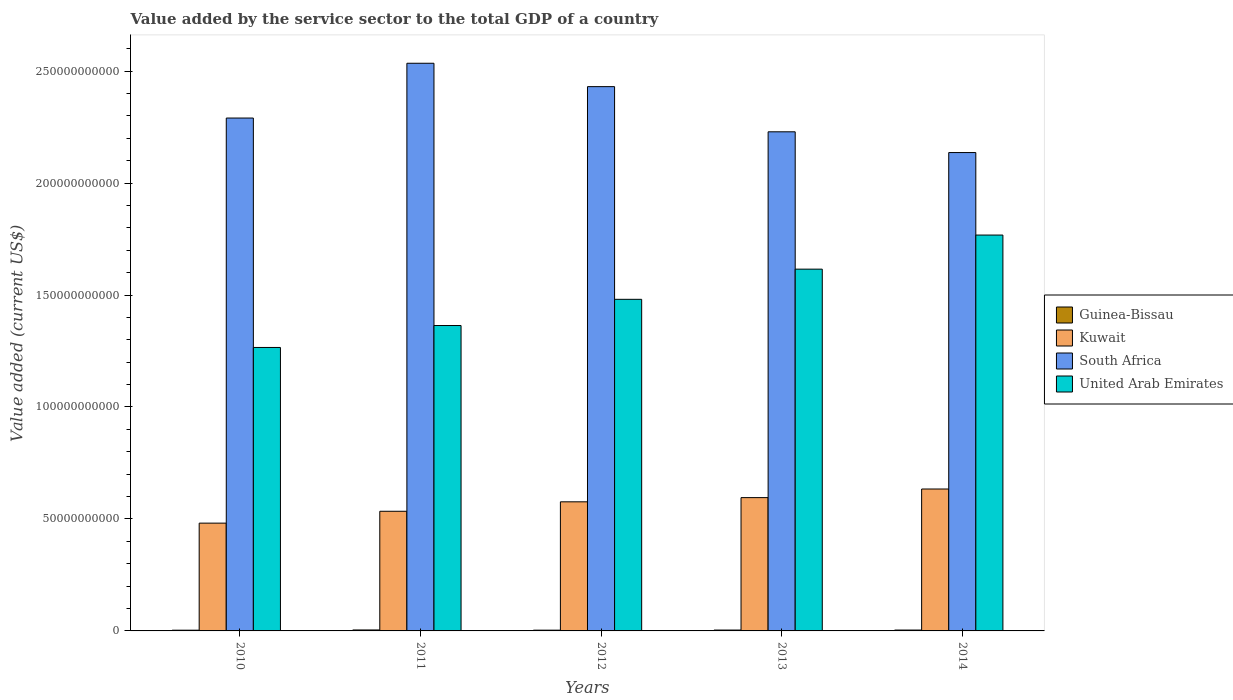Are the number of bars on each tick of the X-axis equal?
Provide a short and direct response. Yes. How many bars are there on the 2nd tick from the left?
Keep it short and to the point. 4. How many bars are there on the 2nd tick from the right?
Ensure brevity in your answer.  4. In how many cases, is the number of bars for a given year not equal to the number of legend labels?
Your answer should be very brief. 0. What is the value added by the service sector to the total GDP in Kuwait in 2013?
Ensure brevity in your answer.  5.95e+1. Across all years, what is the maximum value added by the service sector to the total GDP in Kuwait?
Your response must be concise. 6.34e+1. Across all years, what is the minimum value added by the service sector to the total GDP in Guinea-Bissau?
Your response must be concise. 3.25e+08. In which year was the value added by the service sector to the total GDP in South Africa minimum?
Make the answer very short. 2014. What is the total value added by the service sector to the total GDP in South Africa in the graph?
Give a very brief answer. 1.16e+12. What is the difference between the value added by the service sector to the total GDP in South Africa in 2012 and that in 2013?
Ensure brevity in your answer.  2.02e+1. What is the difference between the value added by the service sector to the total GDP in South Africa in 2012 and the value added by the service sector to the total GDP in Kuwait in 2013?
Your answer should be very brief. 1.84e+11. What is the average value added by the service sector to the total GDP in Kuwait per year?
Make the answer very short. 5.64e+1. In the year 2013, what is the difference between the value added by the service sector to the total GDP in Kuwait and value added by the service sector to the total GDP in Guinea-Bissau?
Offer a terse response. 5.91e+1. In how many years, is the value added by the service sector to the total GDP in Guinea-Bissau greater than 230000000000 US$?
Ensure brevity in your answer.  0. What is the ratio of the value added by the service sector to the total GDP in Guinea-Bissau in 2012 to that in 2013?
Your response must be concise. 0.88. Is the difference between the value added by the service sector to the total GDP in Kuwait in 2013 and 2014 greater than the difference between the value added by the service sector to the total GDP in Guinea-Bissau in 2013 and 2014?
Your answer should be very brief. No. What is the difference between the highest and the second highest value added by the service sector to the total GDP in Kuwait?
Offer a very short reply. 3.85e+09. What is the difference between the highest and the lowest value added by the service sector to the total GDP in United Arab Emirates?
Offer a terse response. 5.02e+1. Is it the case that in every year, the sum of the value added by the service sector to the total GDP in United Arab Emirates and value added by the service sector to the total GDP in Guinea-Bissau is greater than the sum of value added by the service sector to the total GDP in South Africa and value added by the service sector to the total GDP in Kuwait?
Make the answer very short. Yes. What does the 4th bar from the left in 2013 represents?
Keep it short and to the point. United Arab Emirates. What does the 2nd bar from the right in 2013 represents?
Your answer should be compact. South Africa. Are all the bars in the graph horizontal?
Give a very brief answer. No. How many years are there in the graph?
Provide a succinct answer. 5. Where does the legend appear in the graph?
Give a very brief answer. Center right. What is the title of the graph?
Keep it short and to the point. Value added by the service sector to the total GDP of a country. What is the label or title of the X-axis?
Provide a short and direct response. Years. What is the label or title of the Y-axis?
Offer a terse response. Value added (current US$). What is the Value added (current US$) in Guinea-Bissau in 2010?
Provide a succinct answer. 3.25e+08. What is the Value added (current US$) in Kuwait in 2010?
Provide a short and direct response. 4.81e+1. What is the Value added (current US$) in South Africa in 2010?
Offer a terse response. 2.29e+11. What is the Value added (current US$) in United Arab Emirates in 2010?
Give a very brief answer. 1.27e+11. What is the Value added (current US$) of Guinea-Bissau in 2011?
Your answer should be compact. 4.27e+08. What is the Value added (current US$) of Kuwait in 2011?
Keep it short and to the point. 5.34e+1. What is the Value added (current US$) in South Africa in 2011?
Keep it short and to the point. 2.53e+11. What is the Value added (current US$) in United Arab Emirates in 2011?
Provide a succinct answer. 1.36e+11. What is the Value added (current US$) in Guinea-Bissau in 2012?
Give a very brief answer. 3.38e+08. What is the Value added (current US$) in Kuwait in 2012?
Provide a succinct answer. 5.77e+1. What is the Value added (current US$) of South Africa in 2012?
Your answer should be compact. 2.43e+11. What is the Value added (current US$) of United Arab Emirates in 2012?
Keep it short and to the point. 1.48e+11. What is the Value added (current US$) in Guinea-Bissau in 2013?
Your answer should be compact. 3.86e+08. What is the Value added (current US$) of Kuwait in 2013?
Your response must be concise. 5.95e+1. What is the Value added (current US$) of South Africa in 2013?
Your response must be concise. 2.23e+11. What is the Value added (current US$) in United Arab Emirates in 2013?
Offer a very short reply. 1.62e+11. What is the Value added (current US$) in Guinea-Bissau in 2014?
Give a very brief answer. 3.89e+08. What is the Value added (current US$) in Kuwait in 2014?
Give a very brief answer. 6.34e+1. What is the Value added (current US$) of South Africa in 2014?
Keep it short and to the point. 2.14e+11. What is the Value added (current US$) of United Arab Emirates in 2014?
Ensure brevity in your answer.  1.77e+11. Across all years, what is the maximum Value added (current US$) in Guinea-Bissau?
Ensure brevity in your answer.  4.27e+08. Across all years, what is the maximum Value added (current US$) in Kuwait?
Your answer should be compact. 6.34e+1. Across all years, what is the maximum Value added (current US$) of South Africa?
Ensure brevity in your answer.  2.53e+11. Across all years, what is the maximum Value added (current US$) of United Arab Emirates?
Offer a terse response. 1.77e+11. Across all years, what is the minimum Value added (current US$) in Guinea-Bissau?
Keep it short and to the point. 3.25e+08. Across all years, what is the minimum Value added (current US$) of Kuwait?
Give a very brief answer. 4.81e+1. Across all years, what is the minimum Value added (current US$) of South Africa?
Your answer should be very brief. 2.14e+11. Across all years, what is the minimum Value added (current US$) of United Arab Emirates?
Offer a very short reply. 1.27e+11. What is the total Value added (current US$) in Guinea-Bissau in the graph?
Give a very brief answer. 1.87e+09. What is the total Value added (current US$) in Kuwait in the graph?
Your response must be concise. 2.82e+11. What is the total Value added (current US$) in South Africa in the graph?
Provide a succinct answer. 1.16e+12. What is the total Value added (current US$) of United Arab Emirates in the graph?
Offer a terse response. 7.49e+11. What is the difference between the Value added (current US$) in Guinea-Bissau in 2010 and that in 2011?
Your answer should be very brief. -1.02e+08. What is the difference between the Value added (current US$) in Kuwait in 2010 and that in 2011?
Provide a succinct answer. -5.29e+09. What is the difference between the Value added (current US$) of South Africa in 2010 and that in 2011?
Offer a terse response. -2.45e+1. What is the difference between the Value added (current US$) in United Arab Emirates in 2010 and that in 2011?
Offer a terse response. -9.79e+09. What is the difference between the Value added (current US$) of Guinea-Bissau in 2010 and that in 2012?
Offer a terse response. -1.38e+07. What is the difference between the Value added (current US$) in Kuwait in 2010 and that in 2012?
Your answer should be very brief. -9.52e+09. What is the difference between the Value added (current US$) of South Africa in 2010 and that in 2012?
Offer a very short reply. -1.40e+1. What is the difference between the Value added (current US$) in United Arab Emirates in 2010 and that in 2012?
Provide a short and direct response. -2.15e+1. What is the difference between the Value added (current US$) of Guinea-Bissau in 2010 and that in 2013?
Offer a terse response. -6.13e+07. What is the difference between the Value added (current US$) in Kuwait in 2010 and that in 2013?
Offer a very short reply. -1.14e+1. What is the difference between the Value added (current US$) of South Africa in 2010 and that in 2013?
Give a very brief answer. 6.15e+09. What is the difference between the Value added (current US$) in United Arab Emirates in 2010 and that in 2013?
Make the answer very short. -3.50e+1. What is the difference between the Value added (current US$) in Guinea-Bissau in 2010 and that in 2014?
Your response must be concise. -6.46e+07. What is the difference between the Value added (current US$) in Kuwait in 2010 and that in 2014?
Keep it short and to the point. -1.52e+1. What is the difference between the Value added (current US$) of South Africa in 2010 and that in 2014?
Offer a terse response. 1.54e+1. What is the difference between the Value added (current US$) of United Arab Emirates in 2010 and that in 2014?
Ensure brevity in your answer.  -5.02e+1. What is the difference between the Value added (current US$) of Guinea-Bissau in 2011 and that in 2012?
Ensure brevity in your answer.  8.83e+07. What is the difference between the Value added (current US$) in Kuwait in 2011 and that in 2012?
Provide a short and direct response. -4.22e+09. What is the difference between the Value added (current US$) of South Africa in 2011 and that in 2012?
Offer a very short reply. 1.04e+1. What is the difference between the Value added (current US$) in United Arab Emirates in 2011 and that in 2012?
Make the answer very short. -1.17e+1. What is the difference between the Value added (current US$) of Guinea-Bissau in 2011 and that in 2013?
Provide a short and direct response. 4.07e+07. What is the difference between the Value added (current US$) of Kuwait in 2011 and that in 2013?
Offer a very short reply. -6.10e+09. What is the difference between the Value added (current US$) in South Africa in 2011 and that in 2013?
Your answer should be compact. 3.06e+1. What is the difference between the Value added (current US$) in United Arab Emirates in 2011 and that in 2013?
Give a very brief answer. -2.52e+1. What is the difference between the Value added (current US$) in Guinea-Bissau in 2011 and that in 2014?
Give a very brief answer. 3.74e+07. What is the difference between the Value added (current US$) of Kuwait in 2011 and that in 2014?
Provide a short and direct response. -9.94e+09. What is the difference between the Value added (current US$) in South Africa in 2011 and that in 2014?
Keep it short and to the point. 3.99e+1. What is the difference between the Value added (current US$) in United Arab Emirates in 2011 and that in 2014?
Your answer should be compact. -4.04e+1. What is the difference between the Value added (current US$) of Guinea-Bissau in 2012 and that in 2013?
Your response must be concise. -4.76e+07. What is the difference between the Value added (current US$) in Kuwait in 2012 and that in 2013?
Keep it short and to the point. -1.87e+09. What is the difference between the Value added (current US$) of South Africa in 2012 and that in 2013?
Your response must be concise. 2.02e+1. What is the difference between the Value added (current US$) of United Arab Emirates in 2012 and that in 2013?
Offer a terse response. -1.35e+1. What is the difference between the Value added (current US$) in Guinea-Bissau in 2012 and that in 2014?
Ensure brevity in your answer.  -5.08e+07. What is the difference between the Value added (current US$) in Kuwait in 2012 and that in 2014?
Keep it short and to the point. -5.72e+09. What is the difference between the Value added (current US$) of South Africa in 2012 and that in 2014?
Make the answer very short. 2.94e+1. What is the difference between the Value added (current US$) in United Arab Emirates in 2012 and that in 2014?
Your response must be concise. -2.87e+1. What is the difference between the Value added (current US$) of Guinea-Bissau in 2013 and that in 2014?
Offer a terse response. -3.26e+06. What is the difference between the Value added (current US$) in Kuwait in 2013 and that in 2014?
Your response must be concise. -3.85e+09. What is the difference between the Value added (current US$) of South Africa in 2013 and that in 2014?
Give a very brief answer. 9.26e+09. What is the difference between the Value added (current US$) of United Arab Emirates in 2013 and that in 2014?
Offer a very short reply. -1.52e+1. What is the difference between the Value added (current US$) in Guinea-Bissau in 2010 and the Value added (current US$) in Kuwait in 2011?
Your answer should be compact. -5.31e+1. What is the difference between the Value added (current US$) in Guinea-Bissau in 2010 and the Value added (current US$) in South Africa in 2011?
Ensure brevity in your answer.  -2.53e+11. What is the difference between the Value added (current US$) in Guinea-Bissau in 2010 and the Value added (current US$) in United Arab Emirates in 2011?
Provide a short and direct response. -1.36e+11. What is the difference between the Value added (current US$) in Kuwait in 2010 and the Value added (current US$) in South Africa in 2011?
Offer a very short reply. -2.05e+11. What is the difference between the Value added (current US$) of Kuwait in 2010 and the Value added (current US$) of United Arab Emirates in 2011?
Your response must be concise. -8.82e+1. What is the difference between the Value added (current US$) in South Africa in 2010 and the Value added (current US$) in United Arab Emirates in 2011?
Give a very brief answer. 9.27e+1. What is the difference between the Value added (current US$) in Guinea-Bissau in 2010 and the Value added (current US$) in Kuwait in 2012?
Offer a terse response. -5.73e+1. What is the difference between the Value added (current US$) of Guinea-Bissau in 2010 and the Value added (current US$) of South Africa in 2012?
Your response must be concise. -2.43e+11. What is the difference between the Value added (current US$) of Guinea-Bissau in 2010 and the Value added (current US$) of United Arab Emirates in 2012?
Give a very brief answer. -1.48e+11. What is the difference between the Value added (current US$) of Kuwait in 2010 and the Value added (current US$) of South Africa in 2012?
Your answer should be compact. -1.95e+11. What is the difference between the Value added (current US$) of Kuwait in 2010 and the Value added (current US$) of United Arab Emirates in 2012?
Your answer should be very brief. -9.99e+1. What is the difference between the Value added (current US$) in South Africa in 2010 and the Value added (current US$) in United Arab Emirates in 2012?
Keep it short and to the point. 8.10e+1. What is the difference between the Value added (current US$) of Guinea-Bissau in 2010 and the Value added (current US$) of Kuwait in 2013?
Keep it short and to the point. -5.92e+1. What is the difference between the Value added (current US$) in Guinea-Bissau in 2010 and the Value added (current US$) in South Africa in 2013?
Provide a short and direct response. -2.23e+11. What is the difference between the Value added (current US$) in Guinea-Bissau in 2010 and the Value added (current US$) in United Arab Emirates in 2013?
Your answer should be very brief. -1.61e+11. What is the difference between the Value added (current US$) of Kuwait in 2010 and the Value added (current US$) of South Africa in 2013?
Your answer should be very brief. -1.75e+11. What is the difference between the Value added (current US$) of Kuwait in 2010 and the Value added (current US$) of United Arab Emirates in 2013?
Provide a succinct answer. -1.13e+11. What is the difference between the Value added (current US$) in South Africa in 2010 and the Value added (current US$) in United Arab Emirates in 2013?
Provide a succinct answer. 6.75e+1. What is the difference between the Value added (current US$) in Guinea-Bissau in 2010 and the Value added (current US$) in Kuwait in 2014?
Keep it short and to the point. -6.31e+1. What is the difference between the Value added (current US$) in Guinea-Bissau in 2010 and the Value added (current US$) in South Africa in 2014?
Ensure brevity in your answer.  -2.13e+11. What is the difference between the Value added (current US$) of Guinea-Bissau in 2010 and the Value added (current US$) of United Arab Emirates in 2014?
Your response must be concise. -1.76e+11. What is the difference between the Value added (current US$) in Kuwait in 2010 and the Value added (current US$) in South Africa in 2014?
Give a very brief answer. -1.65e+11. What is the difference between the Value added (current US$) in Kuwait in 2010 and the Value added (current US$) in United Arab Emirates in 2014?
Your answer should be compact. -1.29e+11. What is the difference between the Value added (current US$) in South Africa in 2010 and the Value added (current US$) in United Arab Emirates in 2014?
Offer a terse response. 5.23e+1. What is the difference between the Value added (current US$) in Guinea-Bissau in 2011 and the Value added (current US$) in Kuwait in 2012?
Your answer should be very brief. -5.72e+1. What is the difference between the Value added (current US$) of Guinea-Bissau in 2011 and the Value added (current US$) of South Africa in 2012?
Ensure brevity in your answer.  -2.43e+11. What is the difference between the Value added (current US$) of Guinea-Bissau in 2011 and the Value added (current US$) of United Arab Emirates in 2012?
Offer a terse response. -1.48e+11. What is the difference between the Value added (current US$) of Kuwait in 2011 and the Value added (current US$) of South Africa in 2012?
Offer a terse response. -1.90e+11. What is the difference between the Value added (current US$) of Kuwait in 2011 and the Value added (current US$) of United Arab Emirates in 2012?
Give a very brief answer. -9.47e+1. What is the difference between the Value added (current US$) in South Africa in 2011 and the Value added (current US$) in United Arab Emirates in 2012?
Your answer should be compact. 1.05e+11. What is the difference between the Value added (current US$) in Guinea-Bissau in 2011 and the Value added (current US$) in Kuwait in 2013?
Your answer should be very brief. -5.91e+1. What is the difference between the Value added (current US$) in Guinea-Bissau in 2011 and the Value added (current US$) in South Africa in 2013?
Your response must be concise. -2.22e+11. What is the difference between the Value added (current US$) of Guinea-Bissau in 2011 and the Value added (current US$) of United Arab Emirates in 2013?
Provide a succinct answer. -1.61e+11. What is the difference between the Value added (current US$) in Kuwait in 2011 and the Value added (current US$) in South Africa in 2013?
Provide a short and direct response. -1.69e+11. What is the difference between the Value added (current US$) of Kuwait in 2011 and the Value added (current US$) of United Arab Emirates in 2013?
Your response must be concise. -1.08e+11. What is the difference between the Value added (current US$) of South Africa in 2011 and the Value added (current US$) of United Arab Emirates in 2013?
Keep it short and to the point. 9.19e+1. What is the difference between the Value added (current US$) of Guinea-Bissau in 2011 and the Value added (current US$) of Kuwait in 2014?
Your answer should be compact. -6.29e+1. What is the difference between the Value added (current US$) of Guinea-Bissau in 2011 and the Value added (current US$) of South Africa in 2014?
Provide a short and direct response. -2.13e+11. What is the difference between the Value added (current US$) in Guinea-Bissau in 2011 and the Value added (current US$) in United Arab Emirates in 2014?
Give a very brief answer. -1.76e+11. What is the difference between the Value added (current US$) in Kuwait in 2011 and the Value added (current US$) in South Africa in 2014?
Provide a short and direct response. -1.60e+11. What is the difference between the Value added (current US$) in Kuwait in 2011 and the Value added (current US$) in United Arab Emirates in 2014?
Offer a very short reply. -1.23e+11. What is the difference between the Value added (current US$) of South Africa in 2011 and the Value added (current US$) of United Arab Emirates in 2014?
Provide a short and direct response. 7.67e+1. What is the difference between the Value added (current US$) of Guinea-Bissau in 2012 and the Value added (current US$) of Kuwait in 2013?
Provide a succinct answer. -5.92e+1. What is the difference between the Value added (current US$) in Guinea-Bissau in 2012 and the Value added (current US$) in South Africa in 2013?
Your response must be concise. -2.23e+11. What is the difference between the Value added (current US$) of Guinea-Bissau in 2012 and the Value added (current US$) of United Arab Emirates in 2013?
Keep it short and to the point. -1.61e+11. What is the difference between the Value added (current US$) of Kuwait in 2012 and the Value added (current US$) of South Africa in 2013?
Offer a terse response. -1.65e+11. What is the difference between the Value added (current US$) of Kuwait in 2012 and the Value added (current US$) of United Arab Emirates in 2013?
Your answer should be compact. -1.04e+11. What is the difference between the Value added (current US$) of South Africa in 2012 and the Value added (current US$) of United Arab Emirates in 2013?
Your answer should be compact. 8.15e+1. What is the difference between the Value added (current US$) in Guinea-Bissau in 2012 and the Value added (current US$) in Kuwait in 2014?
Your response must be concise. -6.30e+1. What is the difference between the Value added (current US$) in Guinea-Bissau in 2012 and the Value added (current US$) in South Africa in 2014?
Make the answer very short. -2.13e+11. What is the difference between the Value added (current US$) in Guinea-Bissau in 2012 and the Value added (current US$) in United Arab Emirates in 2014?
Provide a short and direct response. -1.76e+11. What is the difference between the Value added (current US$) in Kuwait in 2012 and the Value added (current US$) in South Africa in 2014?
Keep it short and to the point. -1.56e+11. What is the difference between the Value added (current US$) of Kuwait in 2012 and the Value added (current US$) of United Arab Emirates in 2014?
Offer a terse response. -1.19e+11. What is the difference between the Value added (current US$) in South Africa in 2012 and the Value added (current US$) in United Arab Emirates in 2014?
Give a very brief answer. 6.63e+1. What is the difference between the Value added (current US$) of Guinea-Bissau in 2013 and the Value added (current US$) of Kuwait in 2014?
Your answer should be very brief. -6.30e+1. What is the difference between the Value added (current US$) in Guinea-Bissau in 2013 and the Value added (current US$) in South Africa in 2014?
Offer a very short reply. -2.13e+11. What is the difference between the Value added (current US$) in Guinea-Bissau in 2013 and the Value added (current US$) in United Arab Emirates in 2014?
Offer a very short reply. -1.76e+11. What is the difference between the Value added (current US$) of Kuwait in 2013 and the Value added (current US$) of South Africa in 2014?
Your response must be concise. -1.54e+11. What is the difference between the Value added (current US$) in Kuwait in 2013 and the Value added (current US$) in United Arab Emirates in 2014?
Offer a very short reply. -1.17e+11. What is the difference between the Value added (current US$) in South Africa in 2013 and the Value added (current US$) in United Arab Emirates in 2014?
Keep it short and to the point. 4.61e+1. What is the average Value added (current US$) in Guinea-Bissau per year?
Ensure brevity in your answer.  3.73e+08. What is the average Value added (current US$) of Kuwait per year?
Offer a terse response. 5.64e+1. What is the average Value added (current US$) of South Africa per year?
Offer a terse response. 2.32e+11. What is the average Value added (current US$) of United Arab Emirates per year?
Provide a succinct answer. 1.50e+11. In the year 2010, what is the difference between the Value added (current US$) of Guinea-Bissau and Value added (current US$) of Kuwait?
Ensure brevity in your answer.  -4.78e+1. In the year 2010, what is the difference between the Value added (current US$) in Guinea-Bissau and Value added (current US$) in South Africa?
Give a very brief answer. -2.29e+11. In the year 2010, what is the difference between the Value added (current US$) in Guinea-Bissau and Value added (current US$) in United Arab Emirates?
Ensure brevity in your answer.  -1.26e+11. In the year 2010, what is the difference between the Value added (current US$) in Kuwait and Value added (current US$) in South Africa?
Keep it short and to the point. -1.81e+11. In the year 2010, what is the difference between the Value added (current US$) in Kuwait and Value added (current US$) in United Arab Emirates?
Provide a succinct answer. -7.84e+1. In the year 2010, what is the difference between the Value added (current US$) in South Africa and Value added (current US$) in United Arab Emirates?
Ensure brevity in your answer.  1.02e+11. In the year 2011, what is the difference between the Value added (current US$) in Guinea-Bissau and Value added (current US$) in Kuwait?
Offer a very short reply. -5.30e+1. In the year 2011, what is the difference between the Value added (current US$) of Guinea-Bissau and Value added (current US$) of South Africa?
Offer a terse response. -2.53e+11. In the year 2011, what is the difference between the Value added (current US$) in Guinea-Bissau and Value added (current US$) in United Arab Emirates?
Give a very brief answer. -1.36e+11. In the year 2011, what is the difference between the Value added (current US$) of Kuwait and Value added (current US$) of South Africa?
Provide a succinct answer. -2.00e+11. In the year 2011, what is the difference between the Value added (current US$) in Kuwait and Value added (current US$) in United Arab Emirates?
Your response must be concise. -8.29e+1. In the year 2011, what is the difference between the Value added (current US$) of South Africa and Value added (current US$) of United Arab Emirates?
Offer a very short reply. 1.17e+11. In the year 2012, what is the difference between the Value added (current US$) of Guinea-Bissau and Value added (current US$) of Kuwait?
Offer a very short reply. -5.73e+1. In the year 2012, what is the difference between the Value added (current US$) in Guinea-Bissau and Value added (current US$) in South Africa?
Your response must be concise. -2.43e+11. In the year 2012, what is the difference between the Value added (current US$) in Guinea-Bissau and Value added (current US$) in United Arab Emirates?
Your response must be concise. -1.48e+11. In the year 2012, what is the difference between the Value added (current US$) of Kuwait and Value added (current US$) of South Africa?
Your answer should be very brief. -1.85e+11. In the year 2012, what is the difference between the Value added (current US$) in Kuwait and Value added (current US$) in United Arab Emirates?
Provide a short and direct response. -9.04e+1. In the year 2012, what is the difference between the Value added (current US$) in South Africa and Value added (current US$) in United Arab Emirates?
Your answer should be compact. 9.50e+1. In the year 2013, what is the difference between the Value added (current US$) of Guinea-Bissau and Value added (current US$) of Kuwait?
Give a very brief answer. -5.91e+1. In the year 2013, what is the difference between the Value added (current US$) of Guinea-Bissau and Value added (current US$) of South Africa?
Make the answer very short. -2.22e+11. In the year 2013, what is the difference between the Value added (current US$) in Guinea-Bissau and Value added (current US$) in United Arab Emirates?
Provide a succinct answer. -1.61e+11. In the year 2013, what is the difference between the Value added (current US$) in Kuwait and Value added (current US$) in South Africa?
Offer a terse response. -1.63e+11. In the year 2013, what is the difference between the Value added (current US$) in Kuwait and Value added (current US$) in United Arab Emirates?
Your answer should be compact. -1.02e+11. In the year 2013, what is the difference between the Value added (current US$) of South Africa and Value added (current US$) of United Arab Emirates?
Provide a succinct answer. 6.13e+1. In the year 2014, what is the difference between the Value added (current US$) of Guinea-Bissau and Value added (current US$) of Kuwait?
Ensure brevity in your answer.  -6.30e+1. In the year 2014, what is the difference between the Value added (current US$) in Guinea-Bissau and Value added (current US$) in South Africa?
Offer a terse response. -2.13e+11. In the year 2014, what is the difference between the Value added (current US$) in Guinea-Bissau and Value added (current US$) in United Arab Emirates?
Keep it short and to the point. -1.76e+11. In the year 2014, what is the difference between the Value added (current US$) in Kuwait and Value added (current US$) in South Africa?
Offer a very short reply. -1.50e+11. In the year 2014, what is the difference between the Value added (current US$) of Kuwait and Value added (current US$) of United Arab Emirates?
Offer a very short reply. -1.13e+11. In the year 2014, what is the difference between the Value added (current US$) in South Africa and Value added (current US$) in United Arab Emirates?
Your answer should be very brief. 3.68e+1. What is the ratio of the Value added (current US$) in Guinea-Bissau in 2010 to that in 2011?
Your answer should be very brief. 0.76. What is the ratio of the Value added (current US$) in Kuwait in 2010 to that in 2011?
Your response must be concise. 0.9. What is the ratio of the Value added (current US$) in South Africa in 2010 to that in 2011?
Keep it short and to the point. 0.9. What is the ratio of the Value added (current US$) in United Arab Emirates in 2010 to that in 2011?
Keep it short and to the point. 0.93. What is the ratio of the Value added (current US$) in Guinea-Bissau in 2010 to that in 2012?
Provide a succinct answer. 0.96. What is the ratio of the Value added (current US$) of Kuwait in 2010 to that in 2012?
Your answer should be very brief. 0.83. What is the ratio of the Value added (current US$) in South Africa in 2010 to that in 2012?
Provide a short and direct response. 0.94. What is the ratio of the Value added (current US$) in United Arab Emirates in 2010 to that in 2012?
Make the answer very short. 0.85. What is the ratio of the Value added (current US$) in Guinea-Bissau in 2010 to that in 2013?
Ensure brevity in your answer.  0.84. What is the ratio of the Value added (current US$) in Kuwait in 2010 to that in 2013?
Your answer should be very brief. 0.81. What is the ratio of the Value added (current US$) in South Africa in 2010 to that in 2013?
Give a very brief answer. 1.03. What is the ratio of the Value added (current US$) in United Arab Emirates in 2010 to that in 2013?
Offer a terse response. 0.78. What is the ratio of the Value added (current US$) of Guinea-Bissau in 2010 to that in 2014?
Give a very brief answer. 0.83. What is the ratio of the Value added (current US$) in Kuwait in 2010 to that in 2014?
Offer a very short reply. 0.76. What is the ratio of the Value added (current US$) in South Africa in 2010 to that in 2014?
Provide a short and direct response. 1.07. What is the ratio of the Value added (current US$) in United Arab Emirates in 2010 to that in 2014?
Your response must be concise. 0.72. What is the ratio of the Value added (current US$) in Guinea-Bissau in 2011 to that in 2012?
Your answer should be compact. 1.26. What is the ratio of the Value added (current US$) in Kuwait in 2011 to that in 2012?
Offer a very short reply. 0.93. What is the ratio of the Value added (current US$) of South Africa in 2011 to that in 2012?
Your answer should be very brief. 1.04. What is the ratio of the Value added (current US$) in United Arab Emirates in 2011 to that in 2012?
Offer a terse response. 0.92. What is the ratio of the Value added (current US$) in Guinea-Bissau in 2011 to that in 2013?
Make the answer very short. 1.11. What is the ratio of the Value added (current US$) in Kuwait in 2011 to that in 2013?
Give a very brief answer. 0.9. What is the ratio of the Value added (current US$) in South Africa in 2011 to that in 2013?
Give a very brief answer. 1.14. What is the ratio of the Value added (current US$) of United Arab Emirates in 2011 to that in 2013?
Offer a terse response. 0.84. What is the ratio of the Value added (current US$) of Guinea-Bissau in 2011 to that in 2014?
Your response must be concise. 1.1. What is the ratio of the Value added (current US$) in Kuwait in 2011 to that in 2014?
Your response must be concise. 0.84. What is the ratio of the Value added (current US$) of South Africa in 2011 to that in 2014?
Provide a short and direct response. 1.19. What is the ratio of the Value added (current US$) in United Arab Emirates in 2011 to that in 2014?
Provide a short and direct response. 0.77. What is the ratio of the Value added (current US$) of Guinea-Bissau in 2012 to that in 2013?
Ensure brevity in your answer.  0.88. What is the ratio of the Value added (current US$) of Kuwait in 2012 to that in 2013?
Your response must be concise. 0.97. What is the ratio of the Value added (current US$) in South Africa in 2012 to that in 2013?
Provide a short and direct response. 1.09. What is the ratio of the Value added (current US$) in United Arab Emirates in 2012 to that in 2013?
Provide a succinct answer. 0.92. What is the ratio of the Value added (current US$) of Guinea-Bissau in 2012 to that in 2014?
Your answer should be compact. 0.87. What is the ratio of the Value added (current US$) in Kuwait in 2012 to that in 2014?
Your response must be concise. 0.91. What is the ratio of the Value added (current US$) of South Africa in 2012 to that in 2014?
Your answer should be compact. 1.14. What is the ratio of the Value added (current US$) in United Arab Emirates in 2012 to that in 2014?
Make the answer very short. 0.84. What is the ratio of the Value added (current US$) in Guinea-Bissau in 2013 to that in 2014?
Offer a terse response. 0.99. What is the ratio of the Value added (current US$) of Kuwait in 2013 to that in 2014?
Provide a short and direct response. 0.94. What is the ratio of the Value added (current US$) in South Africa in 2013 to that in 2014?
Make the answer very short. 1.04. What is the ratio of the Value added (current US$) in United Arab Emirates in 2013 to that in 2014?
Make the answer very short. 0.91. What is the difference between the highest and the second highest Value added (current US$) of Guinea-Bissau?
Offer a terse response. 3.74e+07. What is the difference between the highest and the second highest Value added (current US$) of Kuwait?
Give a very brief answer. 3.85e+09. What is the difference between the highest and the second highest Value added (current US$) of South Africa?
Give a very brief answer. 1.04e+1. What is the difference between the highest and the second highest Value added (current US$) of United Arab Emirates?
Offer a terse response. 1.52e+1. What is the difference between the highest and the lowest Value added (current US$) of Guinea-Bissau?
Provide a short and direct response. 1.02e+08. What is the difference between the highest and the lowest Value added (current US$) of Kuwait?
Provide a short and direct response. 1.52e+1. What is the difference between the highest and the lowest Value added (current US$) in South Africa?
Make the answer very short. 3.99e+1. What is the difference between the highest and the lowest Value added (current US$) of United Arab Emirates?
Your answer should be very brief. 5.02e+1. 